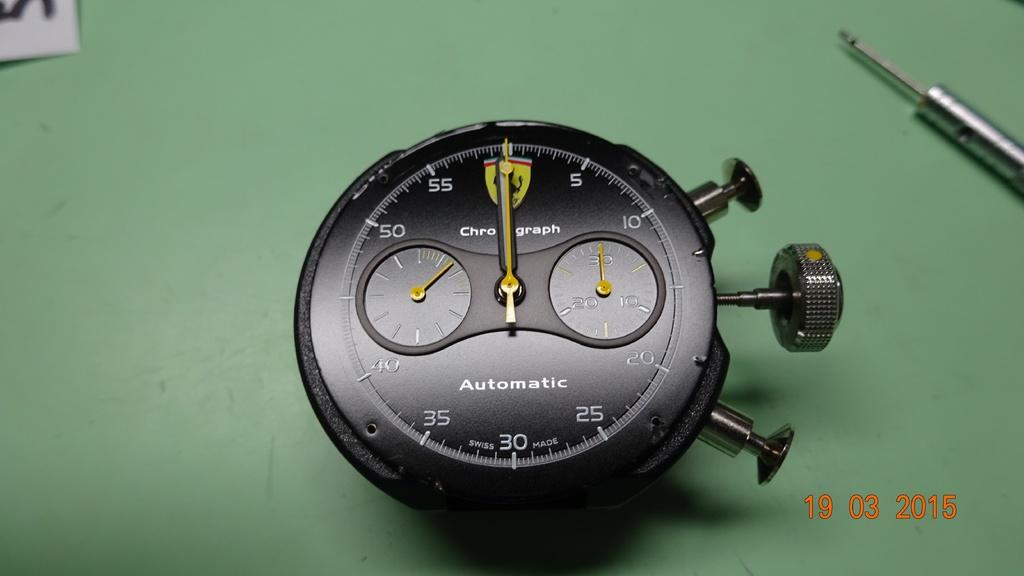<image>
Create a compact narrative representing the image presented. A black and gold Automatic Chronograph displaying 12:00. 